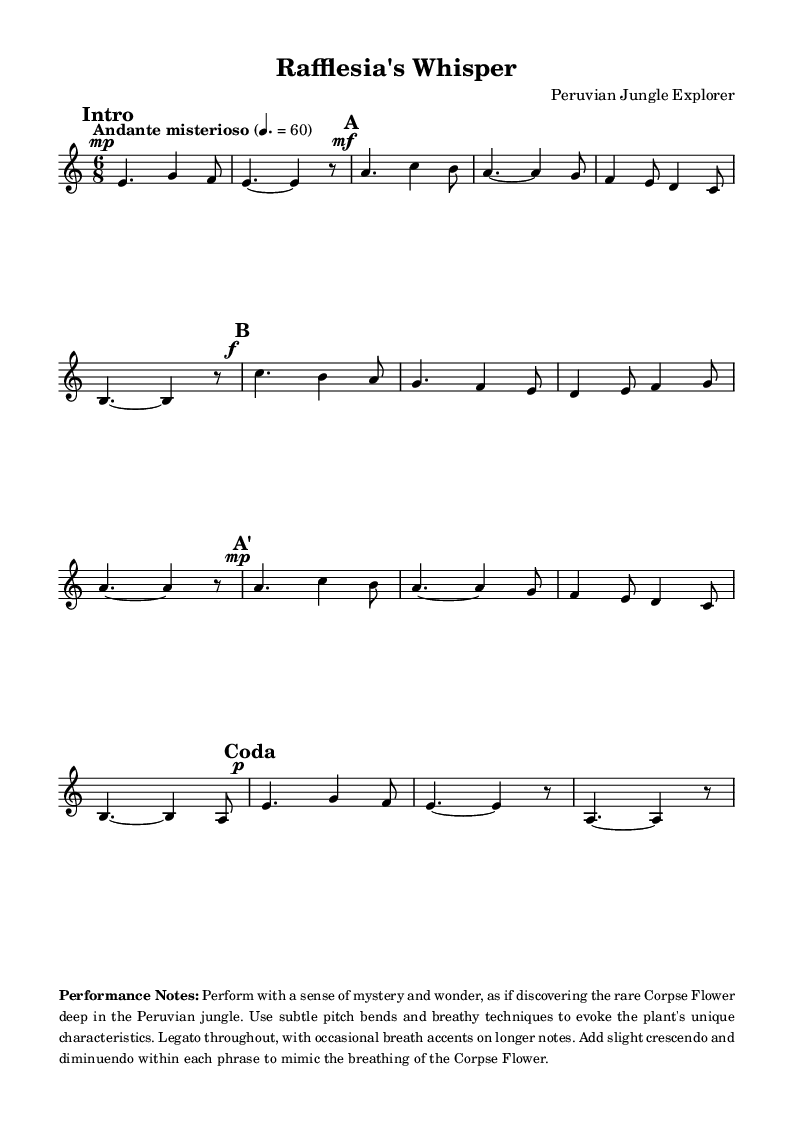What is the time signature of this music? The time signature is indicated at the beginning of the score as 6/8, which means there are six eighth notes per measure.
Answer: 6/8 What is the key signature of this music? The key signature is shown in the score, and it indicates A minor, which has no sharps or flats.
Answer: A minor What tempo marking is given in this piece? The tempo marking is specified as "Andante misterioso," suggesting a moderately slow tempo, contributing to the mysterious character of the music.
Answer: Andante misterioso How many sections are there in the music? The music is divided into five distinct sections labeled "Intro," "A," "B," "A'," and "Coda," which can be counted for the total number of sections.
Answer: 5 What dynamic marking is used at the beginning of section "A"? The dynamic marking at the beginning of section "A" is indicated as "mf," which stands for mezzo-forte, meaning moderately loud.
Answer: mf In what manner should the piece be performed according to the performance notes? The performance notes suggest to play with a sense of mystery and wonder, using subtle pitch bends and breathy techniques to capture the essence of the Corpse Flower.
Answer: Mystery and wonder 